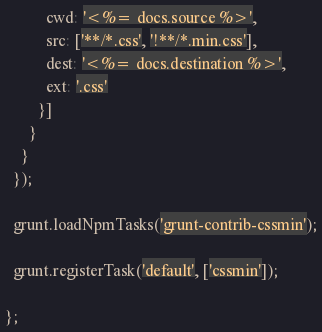Convert code to text. <code><loc_0><loc_0><loc_500><loc_500><_JavaScript_>          cwd: '<%= docs.source %>',
          src: ['**/*.css', '!**/*.min.css'],
          dest: '<%= docs.destination %>',
          ext: '.css'
        }]
      }
    }
  });

  grunt.loadNpmTasks('grunt-contrib-cssmin');

  grunt.registerTask('default', ['cssmin']);

};
</code> 